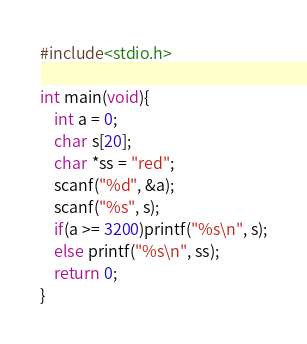<code> <loc_0><loc_0><loc_500><loc_500><_C_>#include<stdio.h>

int main(void){
	int a = 0;
	char s[20];
	char *ss = "red";
	scanf("%d", &a);
	scanf("%s", s);
	if(a >= 3200)printf("%s\n", s);
	else printf("%s\n", ss);
	return 0;
}
</code> 